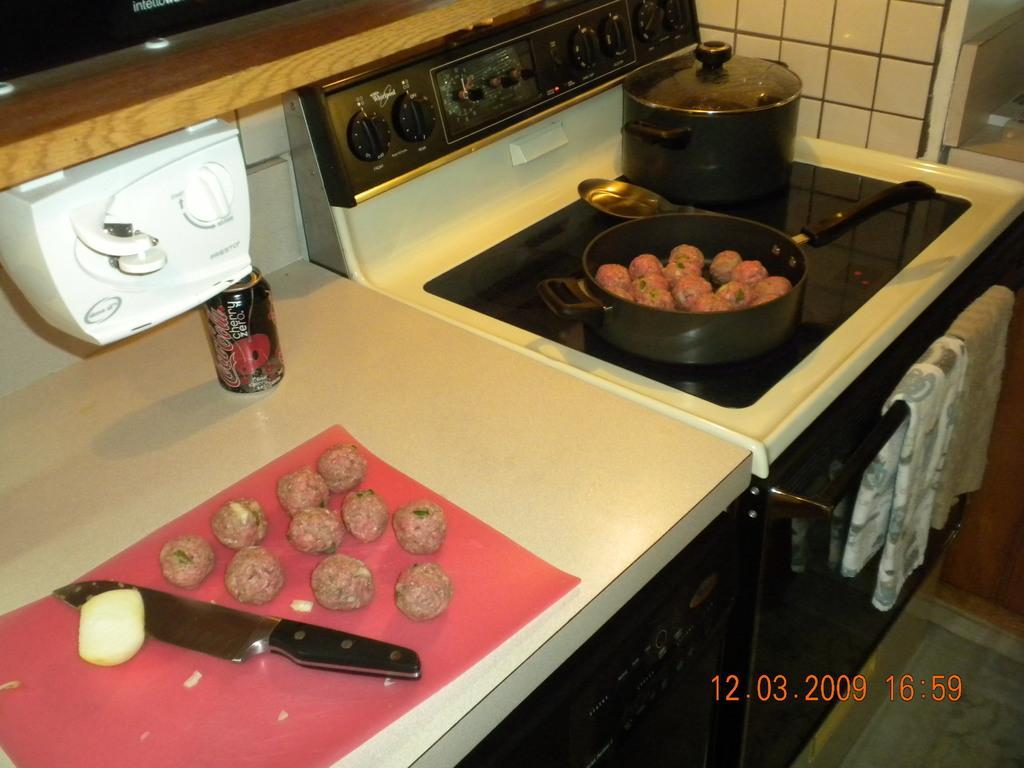Could you give a brief overview of what you see in this image? In this image I see the counter top on which there is a can and I see the white color thing over here and I see a knife and food which is of red and white in color and I see the cloth over here and I see the stove over here and I see the floor and I see the watermark over here. 